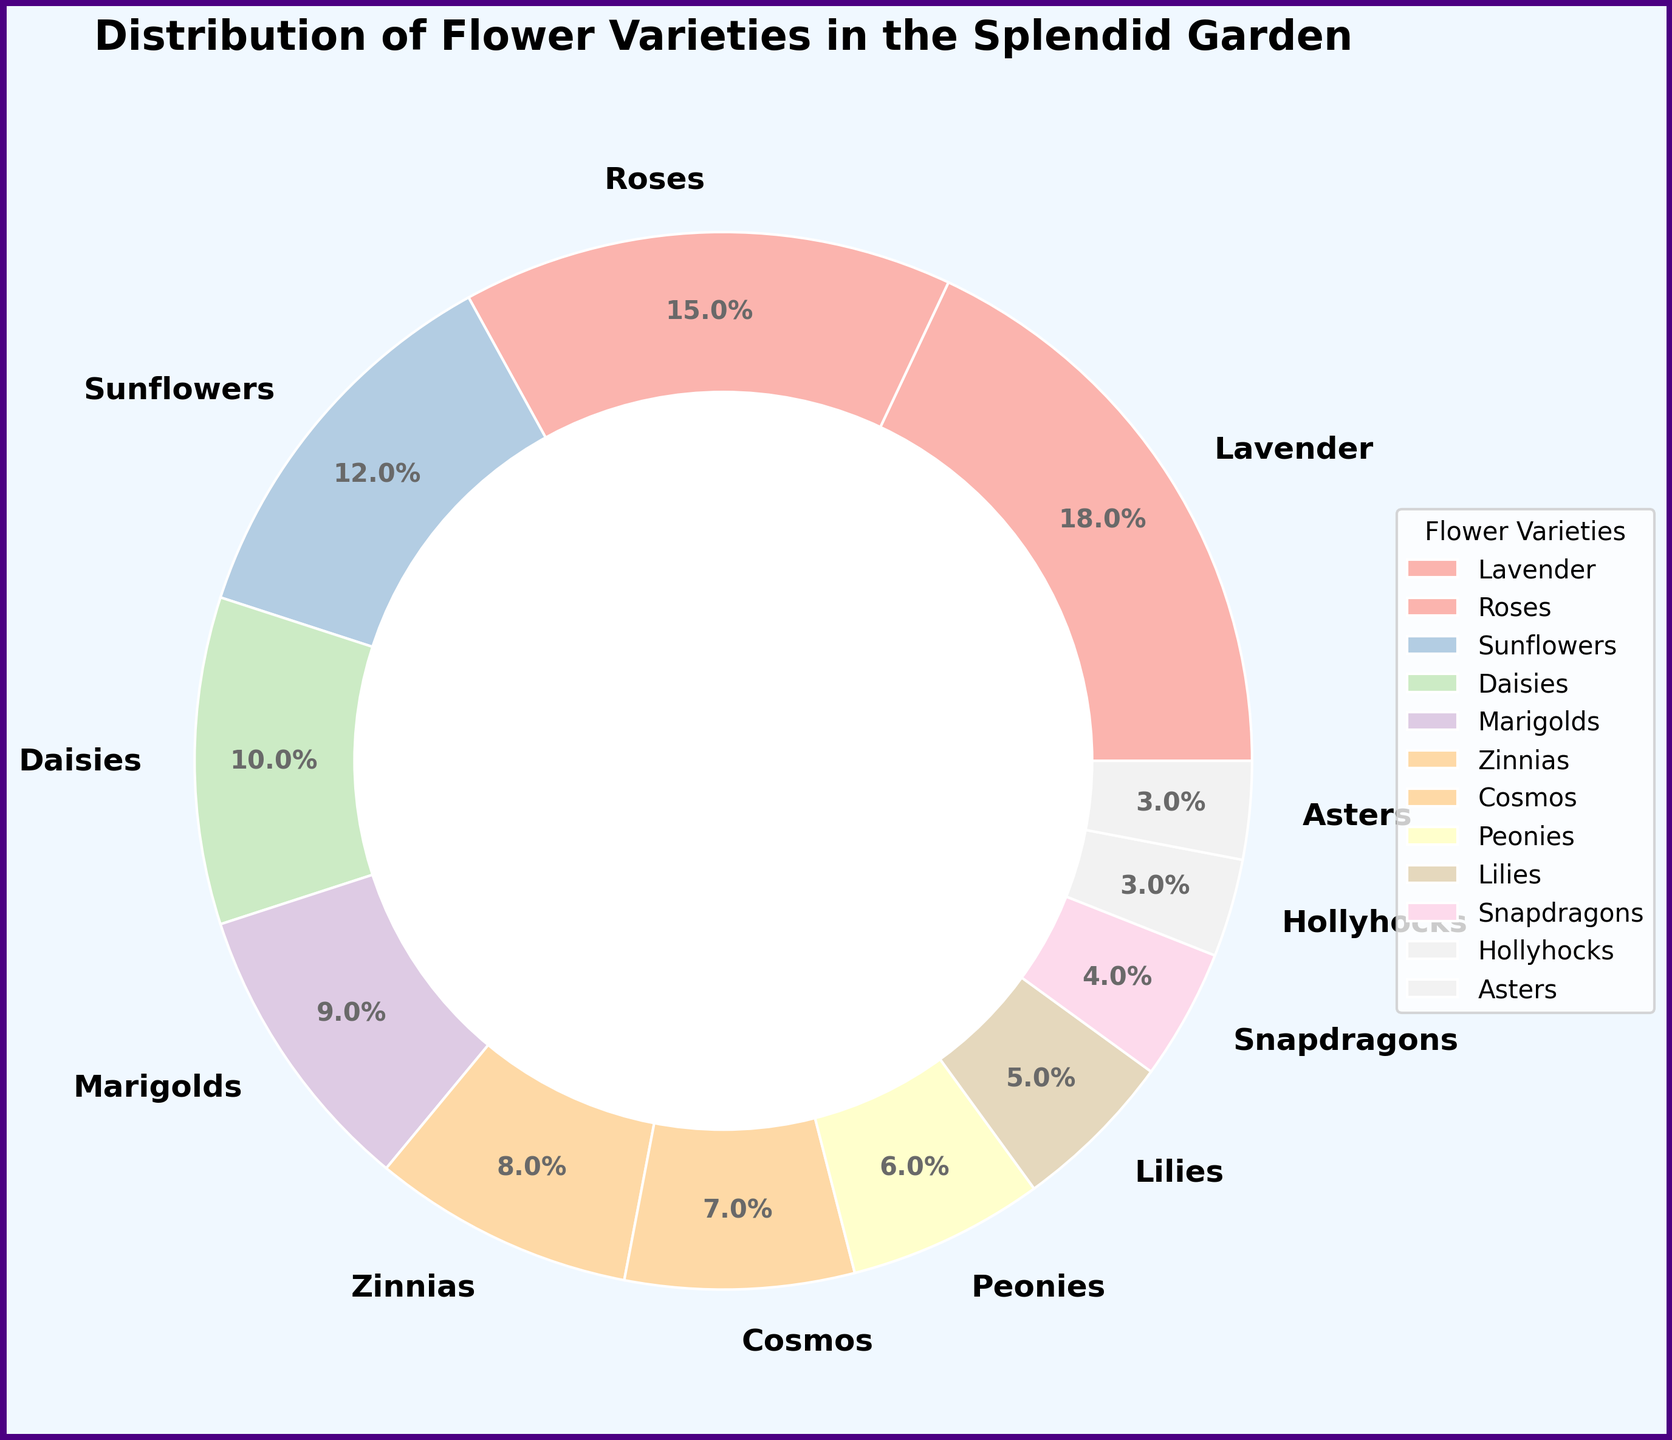what is the percentage of Lavender flowers in the garden? According to the pie chart, Lavender flowers occupy 18% of the garden.
Answer: 18% Which variety of flowers has the second highest percentage? The pie chart shows that Roses, with 15%, have the second highest percentage after Lavender.
Answer: Roses Combine the percentages of Sunflowers and Daisies Sum the percentages of Sunflowers (12%) and Daisies (10%): 12 + 10 = 22%
Answer: 22% Which variety of flowers has a lower percentage: Marigolds or Cosmos? The pie chart indicates Marigolds have 9% while Cosmos have 7%, making Cosmos the variety with a lower percentage.
Answer: Cosmos How much more percentage of the garden is covered by Lilies compared to Snapdragons? According to the pie chart, Lilies cover 5% and Snapdragons cover 4%. The difference is 5% - 4% = 1%.
Answer: 1% Combine the percentages of Peonies, Lilies, and Snapdragons Sum the percentages of Peonies (6%), Lilies (5%), and Snapdragons (4%): 6 + 5 + 4 = 15%
Answer: 15% Which flower varieties each make up exactly 3% of the garden? According to the pie chart, Hollyhocks and Asters each make up 3% of the garden.
Answer: Hollyhocks, Asters What is the combined percentage of all flower varieties that have less than 10% each? Sum the percentages of varieties with less than 10%: 
Zinnias (8%) + Cosmos (7%) + Peonies (6%) + Lilies (5%) + Snapdragons (4%) + Hollyhocks (3%) + Asters (3%) = 36%
Answer: 36% How much more garden space is occupied by the top three flower varieties compared to the bottom three? The top three varieties are Lavender (18%), Roses (15%), and Sunflowers (12%), totaling 18 + 15 + 12 = 45%. The bottom three are Snapdragons (4%), Hollyhocks (3%), and Asters (3%), totaling 4 + 3 + 3 = 10%. The difference is 45% - 10% = 35%.
Answer: 35% 